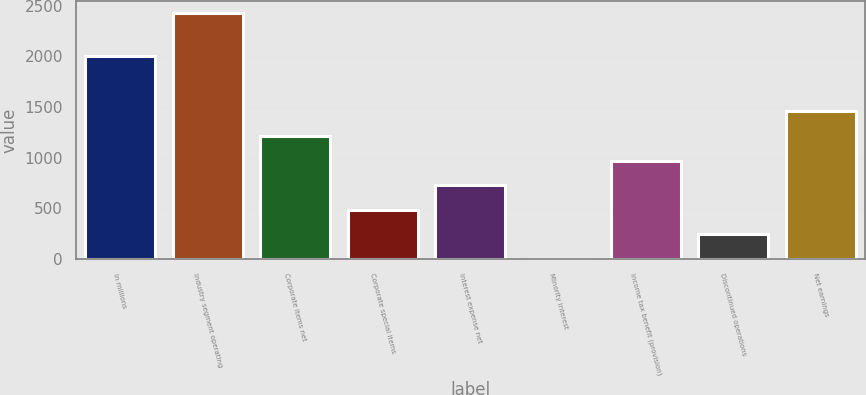<chart> <loc_0><loc_0><loc_500><loc_500><bar_chart><fcel>In millions<fcel>Industry segment operating<fcel>Corporate items net<fcel>Corporate special items<fcel>Interest expense net<fcel>Minority interest<fcel>Income tax benefit (provision)<fcel>Discontinued operations<fcel>Net earnings<nl><fcel>2007<fcel>2423<fcel>1214<fcel>488.6<fcel>730.4<fcel>5<fcel>972.2<fcel>246.8<fcel>1455.8<nl></chart> 